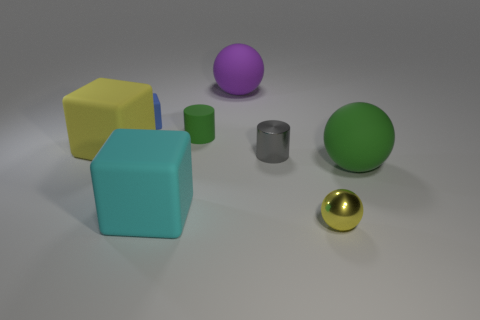Add 2 small objects. How many objects exist? 10 Subtract all yellow balls. How many balls are left? 2 Subtract all big yellow blocks. How many blocks are left? 2 Subtract 1 yellow cubes. How many objects are left? 7 Subtract all spheres. How many objects are left? 5 Subtract 2 cylinders. How many cylinders are left? 0 Subtract all purple blocks. Subtract all yellow cylinders. How many blocks are left? 3 Subtract all red balls. How many blue blocks are left? 1 Subtract all gray shiny cylinders. Subtract all tiny green rubber objects. How many objects are left? 6 Add 6 tiny blue cubes. How many tiny blue cubes are left? 7 